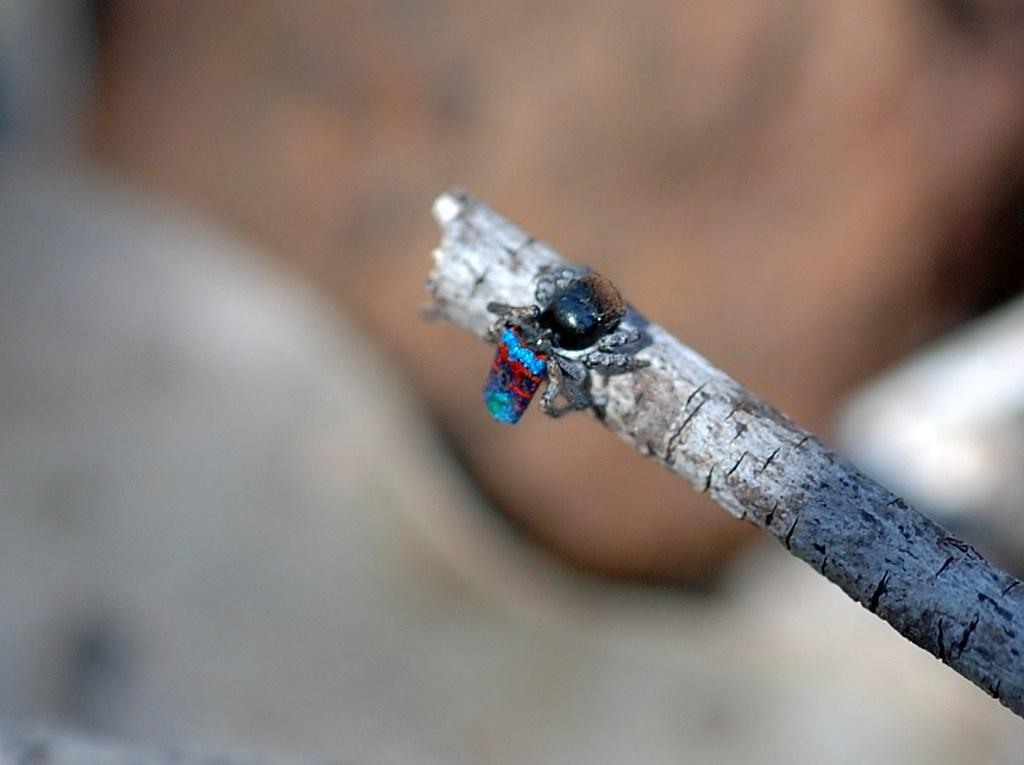What object can be seen in the image? There is a stick in the image. Can you describe the background of the image? The background of the image is blurred. What type of paste is being used to create the shocking effect in the image? There is no paste or shocking effect present in the image; it only features a stick and a blurred background. 